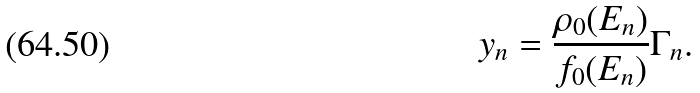<formula> <loc_0><loc_0><loc_500><loc_500>y _ { n } = \frac { \rho _ { 0 } ( E _ { n } ) } { f _ { 0 } ( E _ { n } ) } \Gamma _ { n } .</formula> 